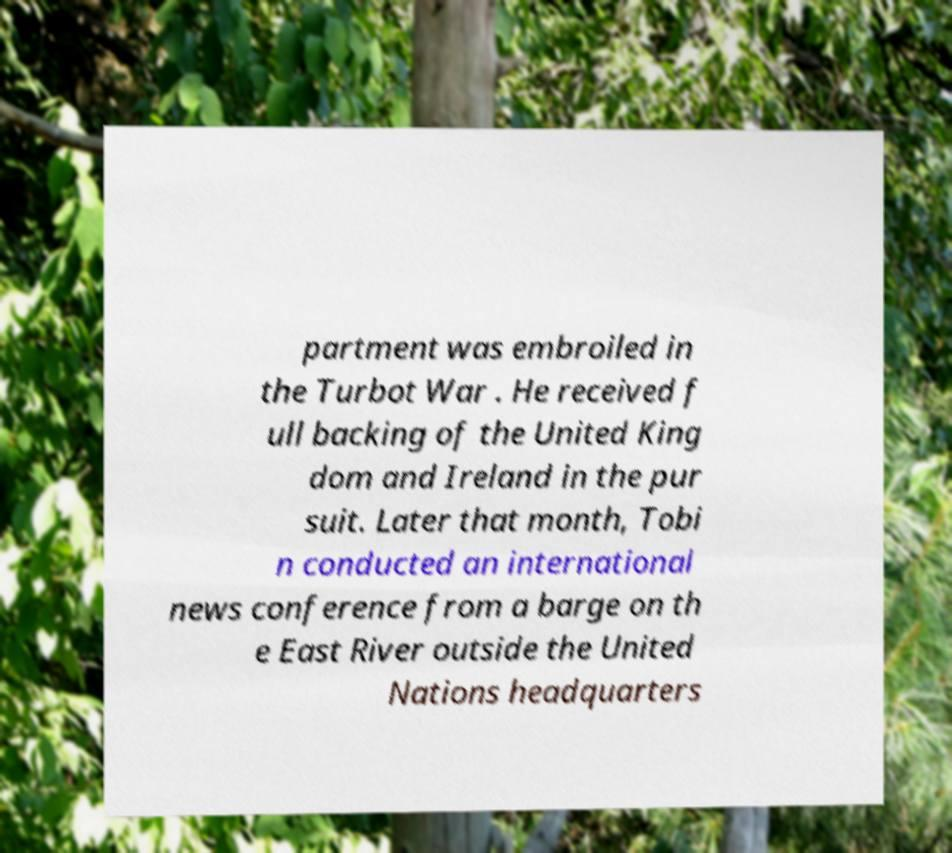There's text embedded in this image that I need extracted. Can you transcribe it verbatim? partment was embroiled in the Turbot War . He received f ull backing of the United King dom and Ireland in the pur suit. Later that month, Tobi n conducted an international news conference from a barge on th e East River outside the United Nations headquarters 